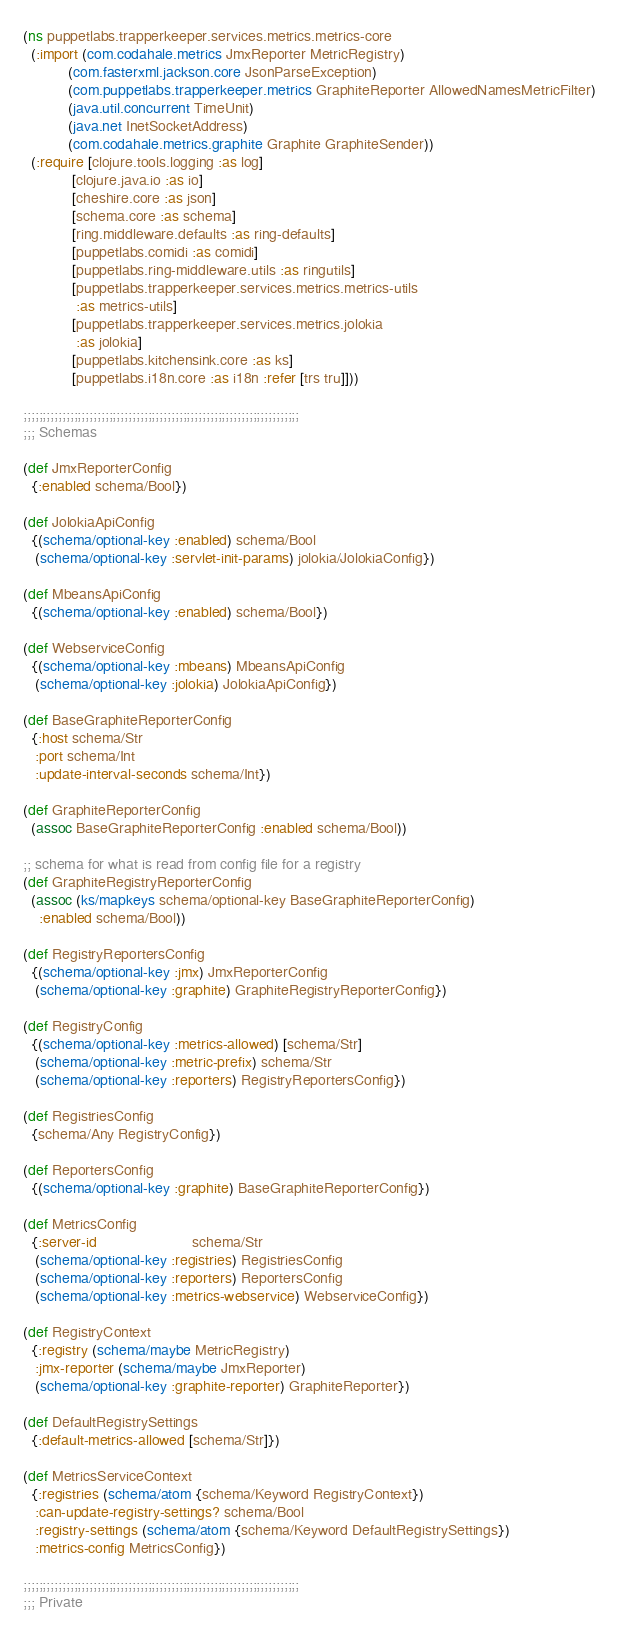<code> <loc_0><loc_0><loc_500><loc_500><_Clojure_>(ns puppetlabs.trapperkeeper.services.metrics.metrics-core
  (:import (com.codahale.metrics JmxReporter MetricRegistry)
           (com.fasterxml.jackson.core JsonParseException)
           (com.puppetlabs.trapperkeeper.metrics GraphiteReporter AllowedNamesMetricFilter)
           (java.util.concurrent TimeUnit)
           (java.net InetSocketAddress)
           (com.codahale.metrics.graphite Graphite GraphiteSender))
  (:require [clojure.tools.logging :as log]
            [clojure.java.io :as io]
            [cheshire.core :as json]
            [schema.core :as schema]
            [ring.middleware.defaults :as ring-defaults]
            [puppetlabs.comidi :as comidi]
            [puppetlabs.ring-middleware.utils :as ringutils]
            [puppetlabs.trapperkeeper.services.metrics.metrics-utils
             :as metrics-utils]
            [puppetlabs.trapperkeeper.services.metrics.jolokia
             :as jolokia]
            [puppetlabs.kitchensink.core :as ks]
            [puppetlabs.i18n.core :as i18n :refer [trs tru]]))

;;;;;;;;;;;;;;;;;;;;;;;;;;;;;;;;;;;;;;;;;;;;;;;;;;;;;;;;;;;;;;;;;;;;;;;
;;; Schemas

(def JmxReporterConfig
  {:enabled schema/Bool})

(def JolokiaApiConfig
  {(schema/optional-key :enabled) schema/Bool
   (schema/optional-key :servlet-init-params) jolokia/JolokiaConfig})

(def MbeansApiConfig
  {(schema/optional-key :enabled) schema/Bool})

(def WebserviceConfig
  {(schema/optional-key :mbeans) MbeansApiConfig
   (schema/optional-key :jolokia) JolokiaApiConfig})

(def BaseGraphiteReporterConfig
  {:host schema/Str
   :port schema/Int
   :update-interval-seconds schema/Int})

(def GraphiteReporterConfig
  (assoc BaseGraphiteReporterConfig :enabled schema/Bool))

;; schema for what is read from config file for a registry
(def GraphiteRegistryReporterConfig
  (assoc (ks/mapkeys schema/optional-key BaseGraphiteReporterConfig)
    :enabled schema/Bool))

(def RegistryReportersConfig
  {(schema/optional-key :jmx) JmxReporterConfig
   (schema/optional-key :graphite) GraphiteRegistryReporterConfig})

(def RegistryConfig
  {(schema/optional-key :metrics-allowed) [schema/Str]
   (schema/optional-key :metric-prefix) schema/Str
   (schema/optional-key :reporters) RegistryReportersConfig})

(def RegistriesConfig
  {schema/Any RegistryConfig})

(def ReportersConfig
  {(schema/optional-key :graphite) BaseGraphiteReporterConfig})

(def MetricsConfig
  {:server-id                       schema/Str
   (schema/optional-key :registries) RegistriesConfig
   (schema/optional-key :reporters) ReportersConfig
   (schema/optional-key :metrics-webservice) WebserviceConfig})

(def RegistryContext
  {:registry (schema/maybe MetricRegistry)
   :jmx-reporter (schema/maybe JmxReporter)
   (schema/optional-key :graphite-reporter) GraphiteReporter})

(def DefaultRegistrySettings
  {:default-metrics-allowed [schema/Str]})

(def MetricsServiceContext
  {:registries (schema/atom {schema/Keyword RegistryContext})
   :can-update-registry-settings? schema/Bool
   :registry-settings (schema/atom {schema/Keyword DefaultRegistrySettings})
   :metrics-config MetricsConfig})

;;;;;;;;;;;;;;;;;;;;;;;;;;;;;;;;;;;;;;;;;;;;;;;;;;;;;;;;;;;;;;;;;;;;;;;
;;; Private
</code> 